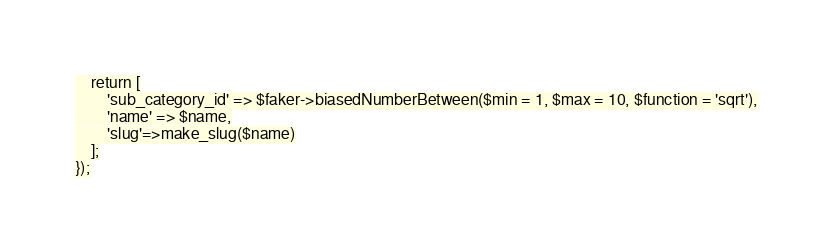Convert code to text. <code><loc_0><loc_0><loc_500><loc_500><_PHP_>    return [
        'sub_category_id' => $faker->biasedNumberBetween($min = 1, $max = 10, $function = 'sqrt'),
        'name' => $name,
        'slug'=>make_slug($name)
    ];
});
</code> 